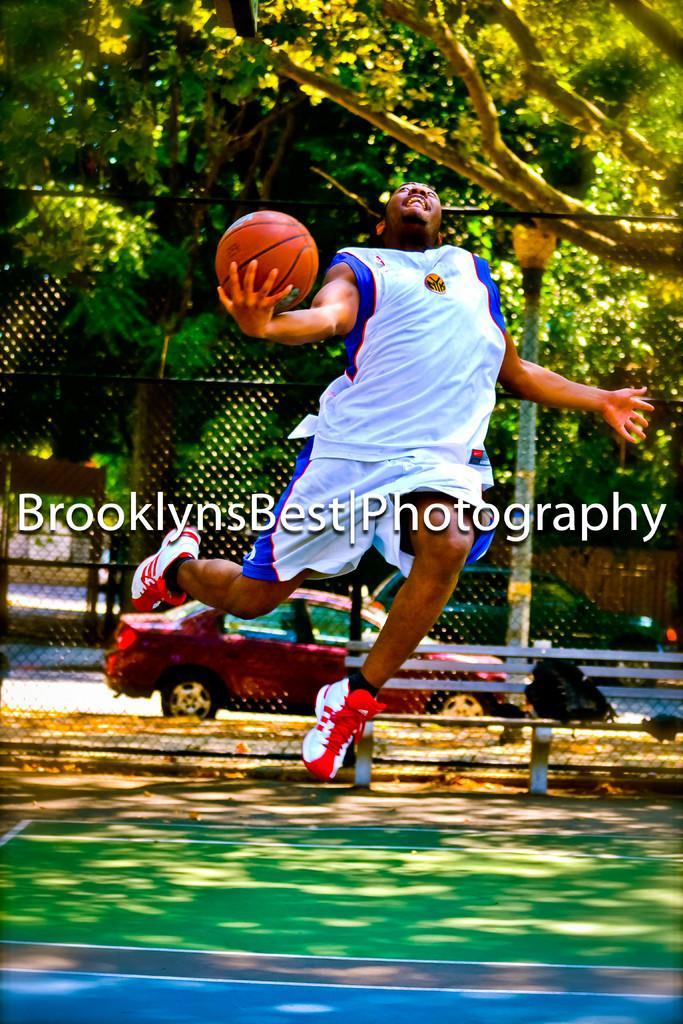How would you summarize this image in a sentence or two? In this image there is a person jumping and holding a ball, and at the background there is a car, wire fence, trees, bench and a watermark on the image. 